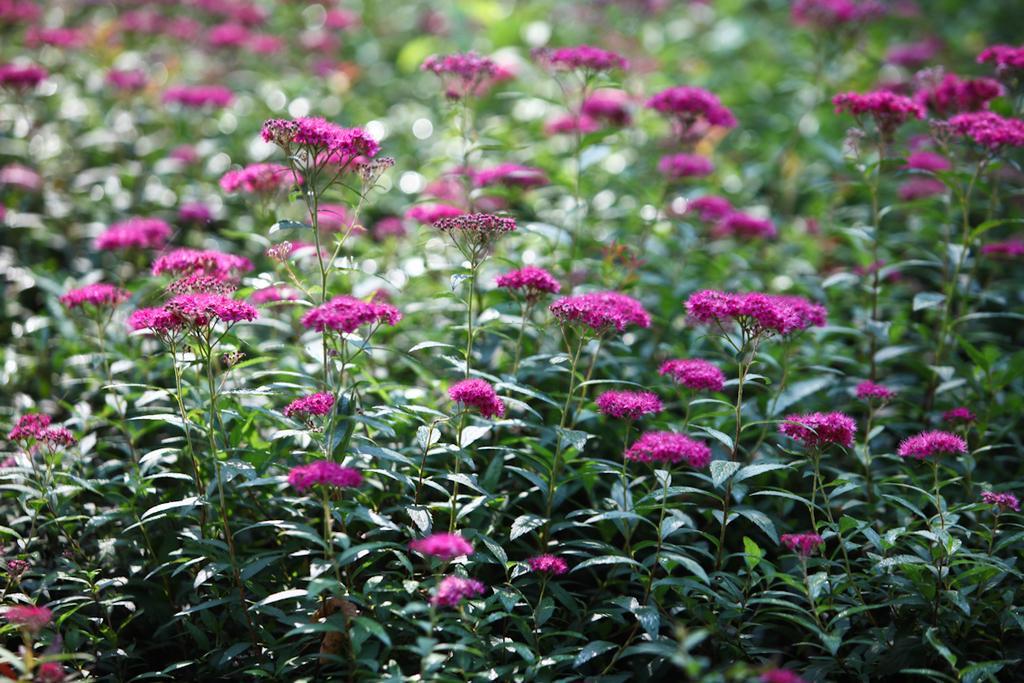Please provide a concise description of this image. In this picture we can see flowers and plants. 